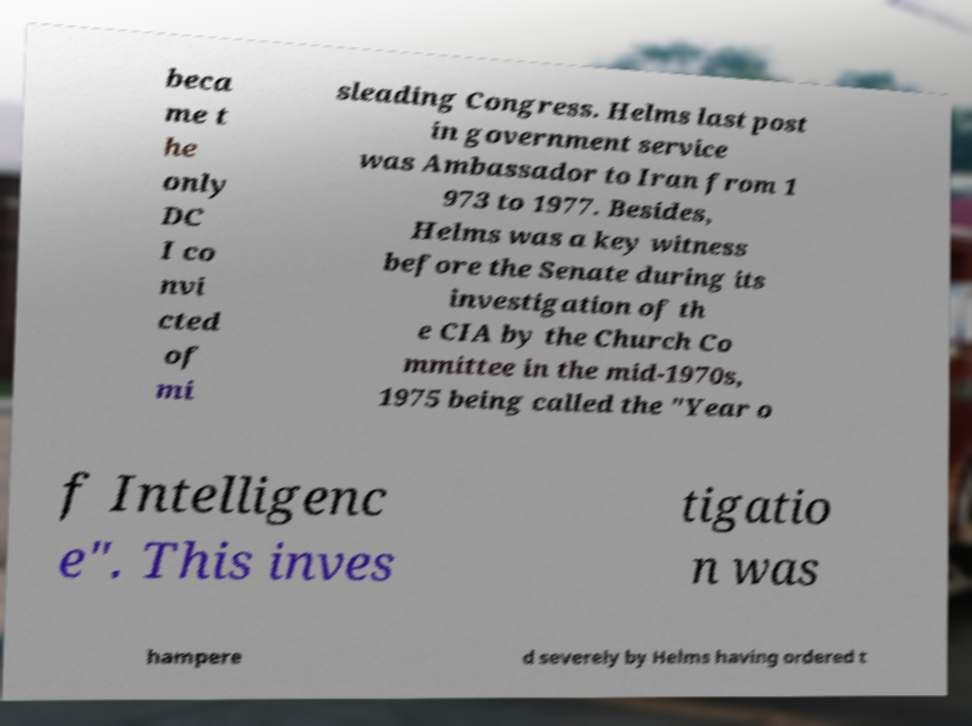Can you accurately transcribe the text from the provided image for me? beca me t he only DC I co nvi cted of mi sleading Congress. Helms last post in government service was Ambassador to Iran from 1 973 to 1977. Besides, Helms was a key witness before the Senate during its investigation of th e CIA by the Church Co mmittee in the mid-1970s, 1975 being called the "Year o f Intelligenc e". This inves tigatio n was hampere d severely by Helms having ordered t 